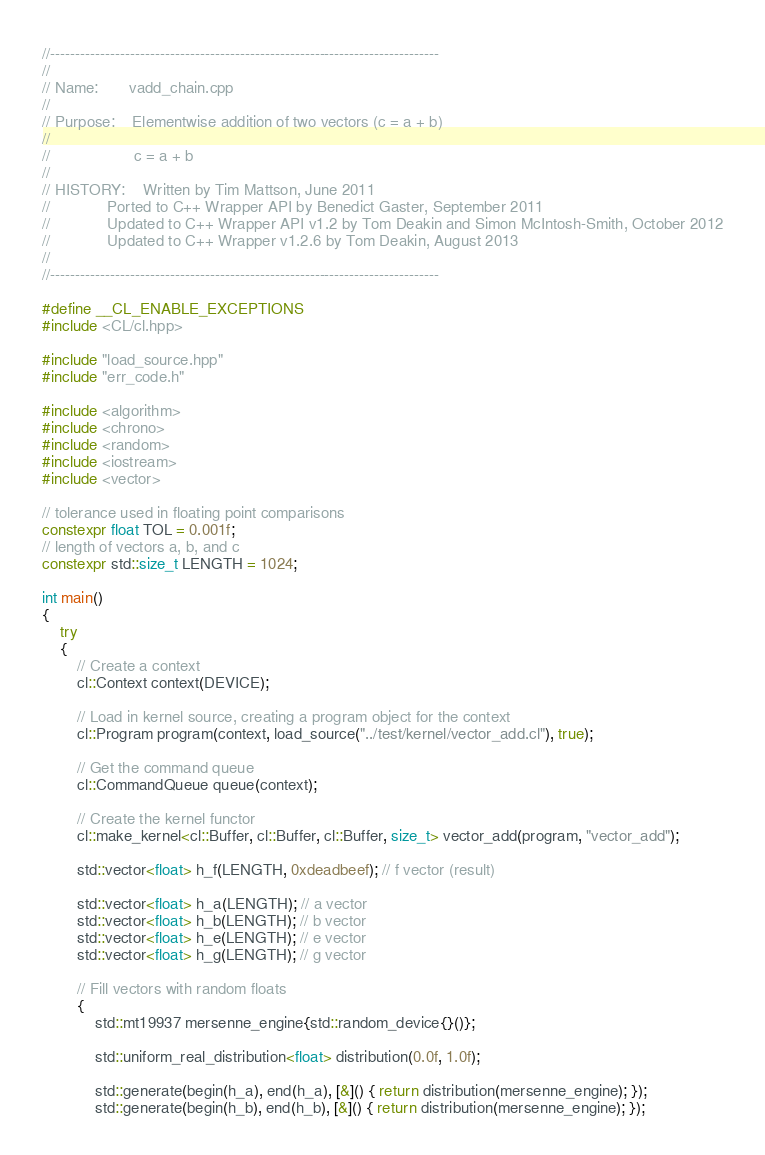Convert code to text. <code><loc_0><loc_0><loc_500><loc_500><_C++_>//------------------------------------------------------------------------------
//
// Name:       vadd_chain.cpp
//
// Purpose:    Elementwise addition of two vectors (c = a + b)
//
//                   c = a + b
//
// HISTORY:    Written by Tim Mattson, June 2011
//             Ported to C++ Wrapper API by Benedict Gaster, September 2011
//             Updated to C++ Wrapper API v1.2 by Tom Deakin and Simon McIntosh-Smith, October 2012
//             Updated to C++ Wrapper v1.2.6 by Tom Deakin, August 2013
//
//------------------------------------------------------------------------------

#define __CL_ENABLE_EXCEPTIONS
#include <CL/cl.hpp>

#include "load_source.hpp"
#include "err_code.h"

#include <algorithm>
#include <chrono>
#include <random>
#include <iostream>
#include <vector>

// tolerance used in floating point comparisons
constexpr float TOL = 0.001f;
// length of vectors a, b, and c
constexpr std::size_t LENGTH = 1024;

int main()
{
    try
    {
        // Create a context
        cl::Context context(DEVICE);

        // Load in kernel source, creating a program object for the context
        cl::Program program(context, load_source("../test/kernel/vector_add.cl"), true);

        // Get the command queue
        cl::CommandQueue queue(context);

        // Create the kernel functor
        cl::make_kernel<cl::Buffer, cl::Buffer, cl::Buffer, size_t> vector_add(program, "vector_add");

        std::vector<float> h_f(LENGTH, 0xdeadbeef); // f vector (result)

        std::vector<float> h_a(LENGTH); // a vector
        std::vector<float> h_b(LENGTH); // b vector
        std::vector<float> h_e(LENGTH); // e vector
        std::vector<float> h_g(LENGTH); // g vector

        // Fill vectors with random floats
        {
            std::mt19937 mersenne_engine{std::random_device{}()};

            std::uniform_real_distribution<float> distribution(0.0f, 1.0f);

            std::generate(begin(h_a), end(h_a), [&]() { return distribution(mersenne_engine); });
            std::generate(begin(h_b), end(h_b), [&]() { return distribution(mersenne_engine); });</code> 